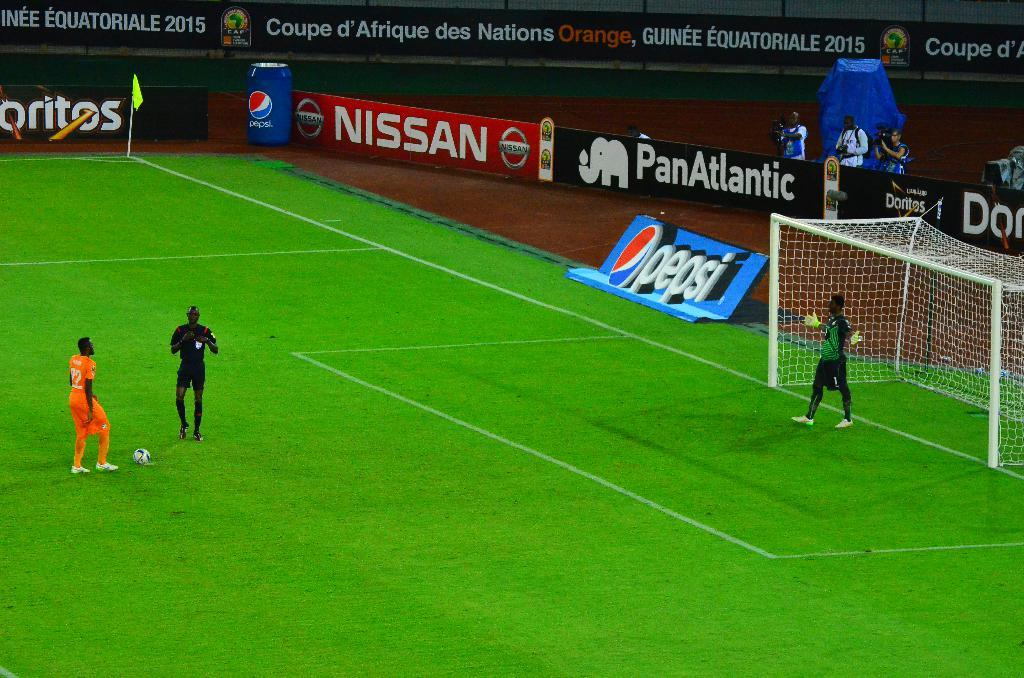<image>
Share a concise interpretation of the image provided. A soccer field with an ad for Pepsi and Nissan 